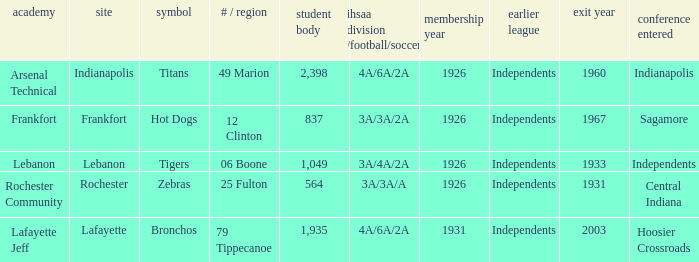What is the lowest enrollment that has Lafayette as the location? 1935.0. 